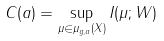Convert formula to latex. <formula><loc_0><loc_0><loc_500><loc_500>C ( a ) = \sup _ { \mu \in \mu _ { g , a } ( X ) } I ( \mu ; W )</formula> 